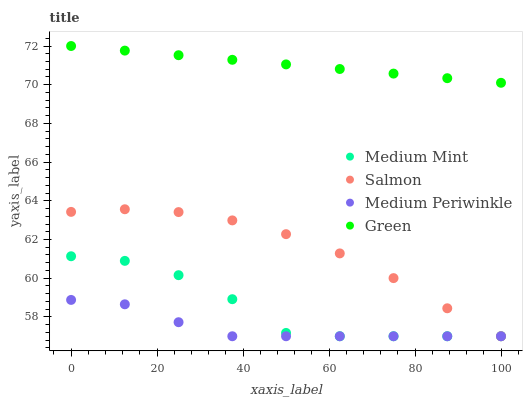Does Medium Periwinkle have the minimum area under the curve?
Answer yes or no. Yes. Does Green have the maximum area under the curve?
Answer yes or no. Yes. Does Green have the minimum area under the curve?
Answer yes or no. No. Does Medium Periwinkle have the maximum area under the curve?
Answer yes or no. No. Is Green the smoothest?
Answer yes or no. Yes. Is Medium Mint the roughest?
Answer yes or no. Yes. Is Medium Periwinkle the smoothest?
Answer yes or no. No. Is Medium Periwinkle the roughest?
Answer yes or no. No. Does Medium Mint have the lowest value?
Answer yes or no. Yes. Does Green have the lowest value?
Answer yes or no. No. Does Green have the highest value?
Answer yes or no. Yes. Does Medium Periwinkle have the highest value?
Answer yes or no. No. Is Medium Periwinkle less than Green?
Answer yes or no. Yes. Is Green greater than Medium Periwinkle?
Answer yes or no. Yes. Does Medium Mint intersect Salmon?
Answer yes or no. Yes. Is Medium Mint less than Salmon?
Answer yes or no. No. Is Medium Mint greater than Salmon?
Answer yes or no. No. Does Medium Periwinkle intersect Green?
Answer yes or no. No. 